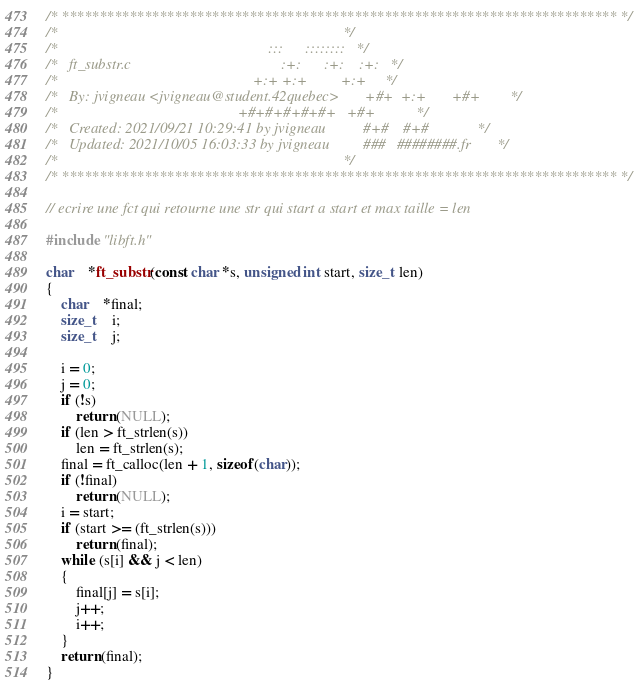<code> <loc_0><loc_0><loc_500><loc_500><_C_>/* ************************************************************************** */
/*                                                                            */
/*                                                        :::      ::::::::   */
/*   ft_substr.c                                        :+:      :+:    :+:   */
/*                                                    +:+ +:+         +:+     */
/*   By: jvigneau <jvigneau@student.42quebec>       +#+  +:+       +#+        */
/*                                                +#+#+#+#+#+   +#+           */
/*   Created: 2021/09/21 10:29:41 by jvigneau          #+#    #+#             */
/*   Updated: 2021/10/05 16:03:33 by jvigneau         ###   ########.fr       */
/*                                                                            */
/* ************************************************************************** */

// ecrire une fct qui retourne une str qui start a start et max taille = len

#include "libft.h"

char	*ft_substr(const char *s, unsigned int start, size_t len)
{
	char	*final;
	size_t	i;
	size_t	j;

	i = 0;
	j = 0;
	if (!s)
		return (NULL);
	if (len > ft_strlen(s))
		len = ft_strlen(s);
	final = ft_calloc(len + 1, sizeof(char));
	if (!final)
		return (NULL);
	i = start;
	if (start >= (ft_strlen(s)))
		return (final);
	while (s[i] && j < len)
	{
		final[j] = s[i];
		j++;
		i++;
	}
	return (final);
}
</code> 